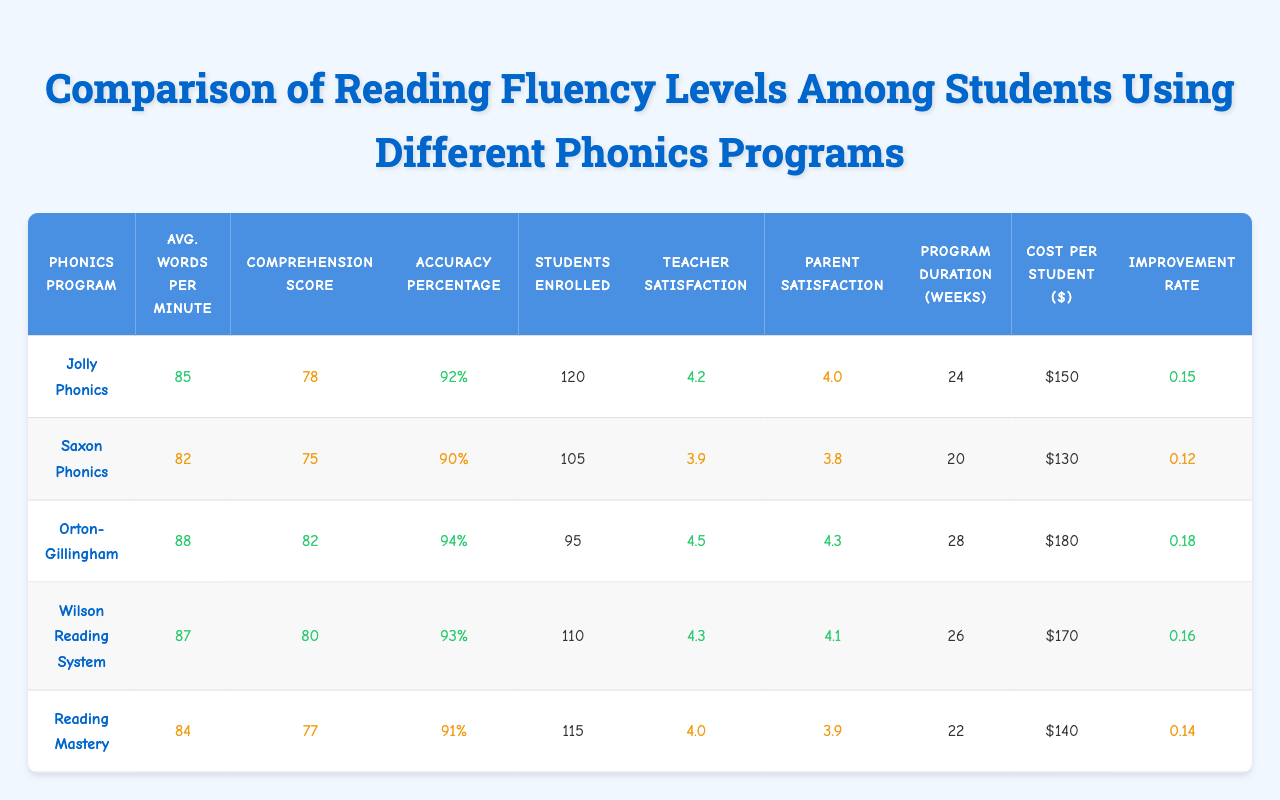What is the highest average words per minute among the phonics programs? To find the highest average words per minute, we look at the averages listed for each program: 85, 82, 88, 87, and 84. The highest value is 88 for the Orton-Gillingham program.
Answer: 88 Which phonics program has the lowest comprehension score? The comprehension scores for the programs are: 78, 75, 82, 80, and 77. The lowest score is 75 for Saxon Phonics.
Answer: Saxon Phonics How many students are enrolled in the Wilson Reading System? Referring to the table, the number of students enrolled in the Wilson Reading System is stated as 110.
Answer: 110 What is the average teacher satisfaction score across all phonics programs? To find the average satisfaction, sum the scores: 4.2 + 3.9 + 4.5 + 4.3 + 4.0 = 20.9. There are 5 programs, so the average is 20.9 / 5 = 4.18, which can be approximated to 4.2.
Answer: 4.2 Is the average accuracy percentage for Jolly Phonics above 90%? The accuracy percentage for Jolly Phonics is 92%. Since 92% is greater than 90%, the statement is true.
Answer: Yes Which program has the longest duration? The program duration weeks are as follows: 24, 20, 28, 26, and 22. The longest duration, 28 weeks, belongs to Orton-Gillingham.
Answer: Orton-Gillingham What is the improvement rate for Reading Mastery? The improvement rate listed for Reading Mastery is 0.14.
Answer: 0.14 Compare the teacher satisfaction scores of Reading Mastery and Saxon Phonics. The teacher satisfaction for Reading Mastery is 4.0, while for Saxon Phonics, it is 3.9. Reading Mastery has a slightly higher teacher satisfaction score by 0.1.
Answer: Reading Mastery is higher by 0.1 Based on accuracy percentages, which program performed best? Looking at the accuracy percentages: 92%, 90%, 94%, 93%, and 91%, Orton-Gillingham at 94% performs the best.
Answer: Orton-Gillingham What is the cost difference between the most and least expensive phonics programs per student? The costs are: 150, 130, 180, 170, and 140. The most expensive is 180 (Orton-Gillingham) and the least expensive is 130 (Saxon Phonics). The difference is 180 - 130 = 50.
Answer: 50 Which phonics program has the highest student enrollment? The enrollment numbers are: 120, 105, 95, 110, and 115. The highest is 120 for Jolly Phonics.
Answer: Jolly Phonics If we consider only programs with a comprehension score above 80, how many are there? The programs with scores above 80 are Orton-Gillingham (82), Wilson Reading System (80), and Reading Mastery (77). Only 2 programs have scores above 80 (Orton-Gillingham and Wilson Reading System).
Answer: 2 